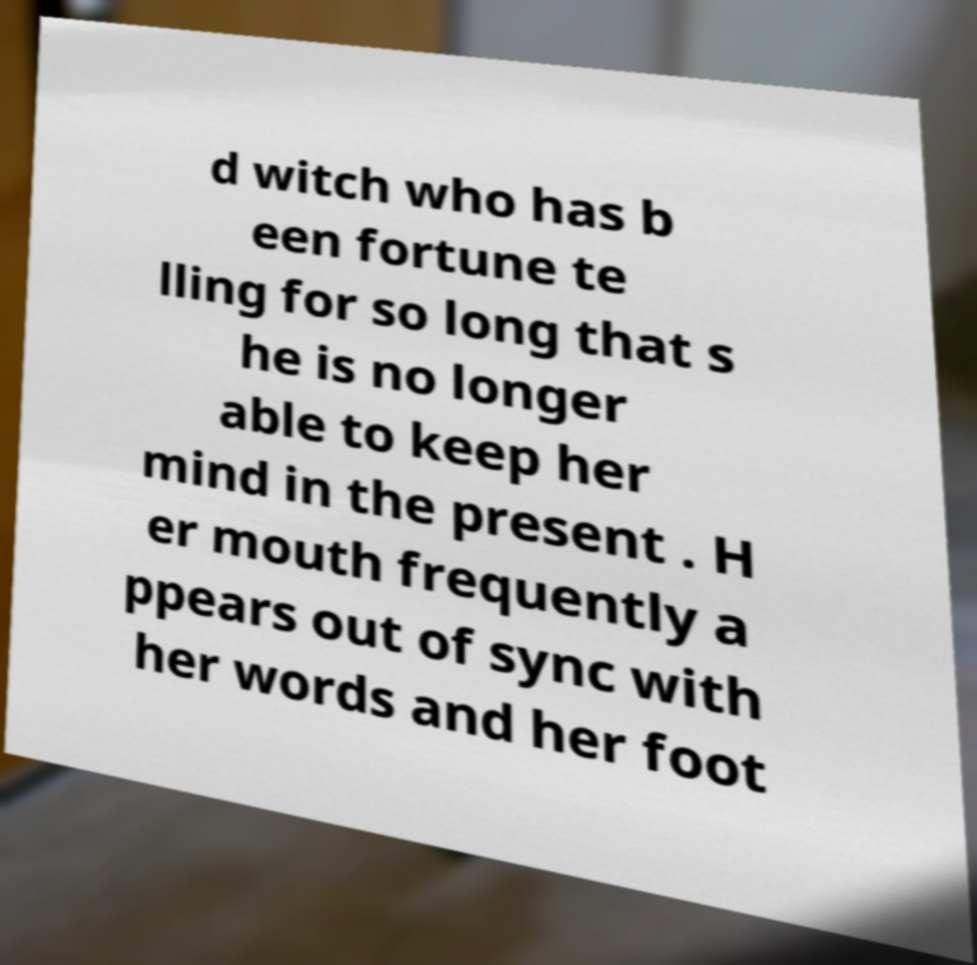Could you extract and type out the text from this image? d witch who has b een fortune te lling for so long that s he is no longer able to keep her mind in the present . H er mouth frequently a ppears out of sync with her words and her foot 